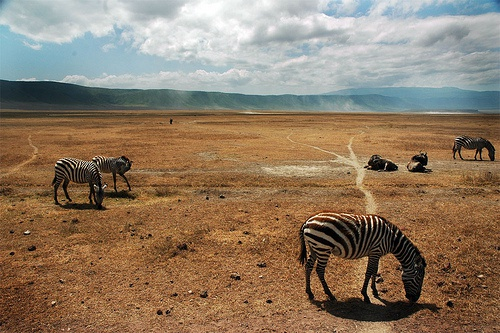Describe the objects in this image and their specific colors. I can see zebra in gray, black, and maroon tones, zebra in gray, black, and maroon tones, zebra in gray, black, and maroon tones, and zebra in gray, black, and maroon tones in this image. 